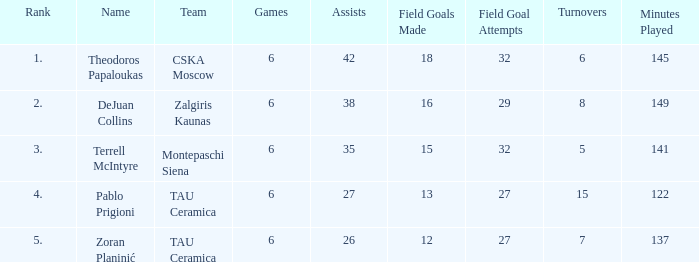What is the least number of assists among players ranked 2? 38.0. 